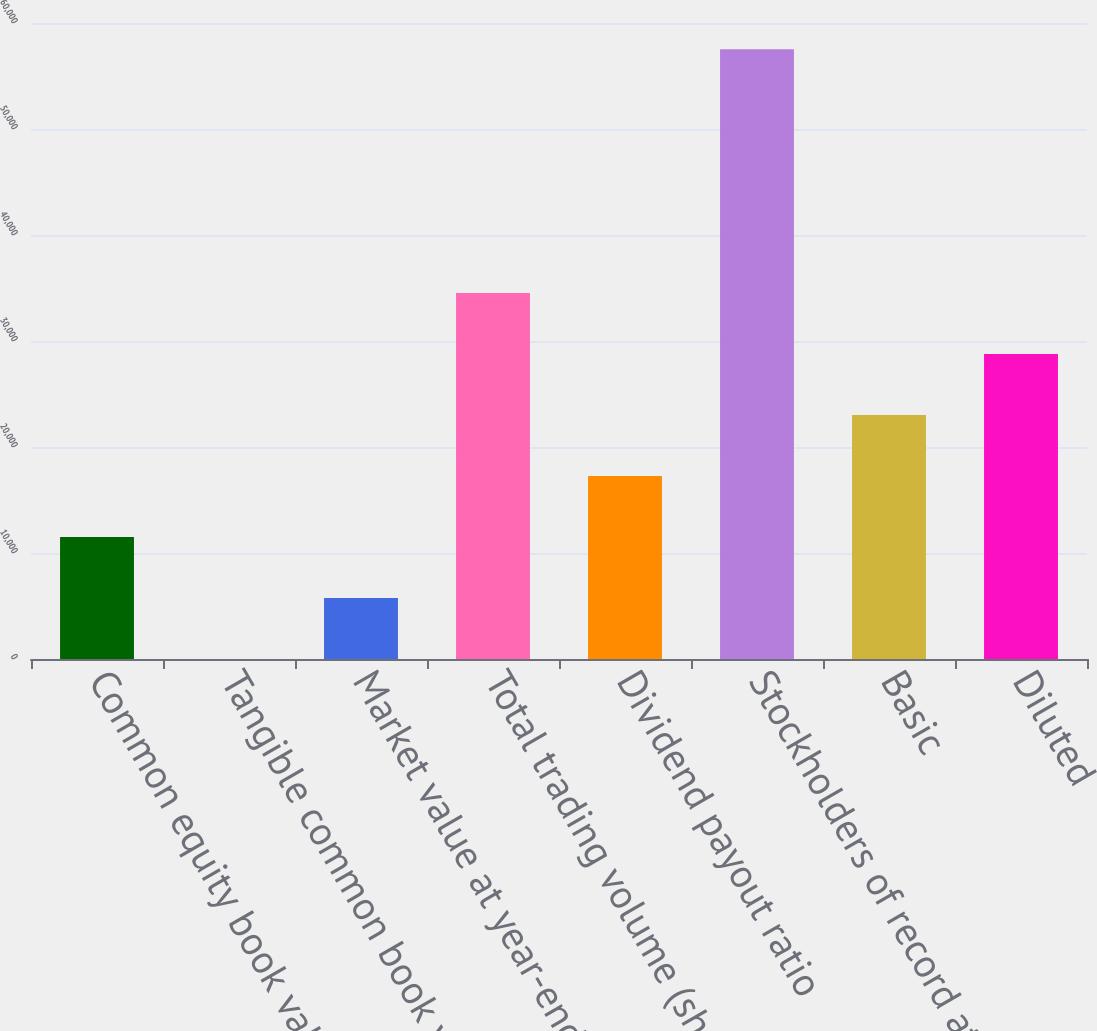Convert chart. <chart><loc_0><loc_0><loc_500><loc_500><bar_chart><fcel>Common equity book value per<fcel>Tangible common book value per<fcel>Market value at year-end<fcel>Total trading volume (shares)<fcel>Dividend payout ratio<fcel>Stockholders of record at<fcel>Basic<fcel>Diluted<nl><fcel>11512.3<fcel>8.18<fcel>5760.26<fcel>34520.7<fcel>17264.4<fcel>57529<fcel>23016.5<fcel>28768.6<nl></chart> 